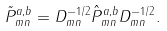<formula> <loc_0><loc_0><loc_500><loc_500>\tilde { P } _ { m n } ^ { a , b } = D _ { m n } ^ { - 1 / 2 } \hat { P } _ { m n } ^ { a , b } D _ { m n } ^ { - 1 / 2 } .</formula> 